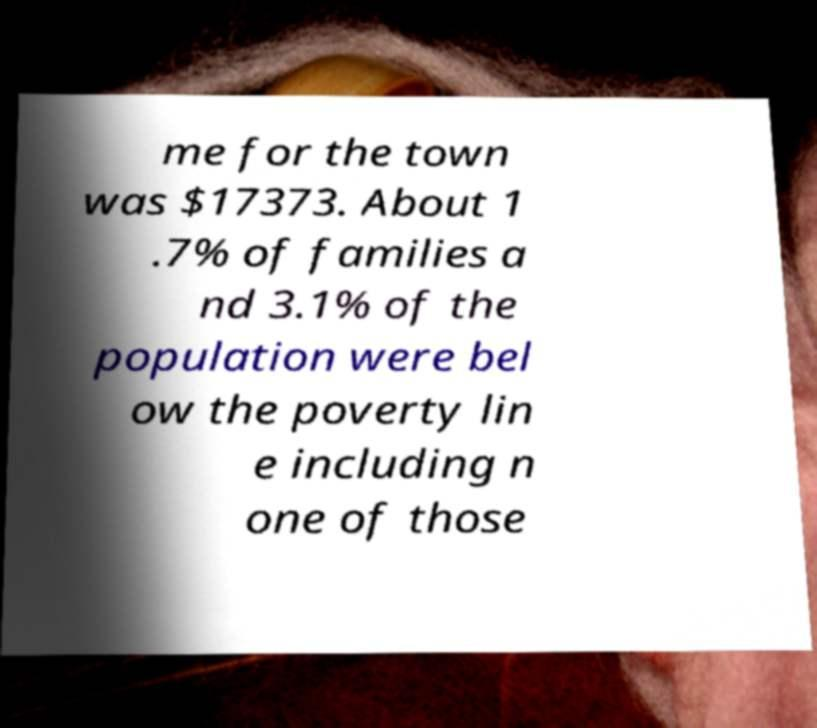Please read and relay the text visible in this image. What does it say? me for the town was $17373. About 1 .7% of families a nd 3.1% of the population were bel ow the poverty lin e including n one of those 